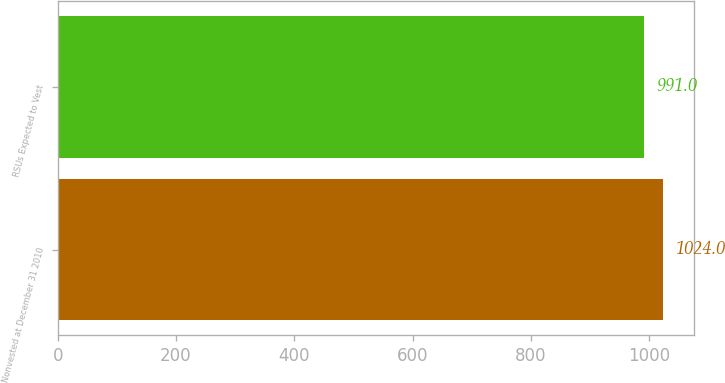Convert chart. <chart><loc_0><loc_0><loc_500><loc_500><bar_chart><fcel>Nonvested at December 31 2010<fcel>RSUs Expected to Vest<nl><fcel>1024<fcel>991<nl></chart> 